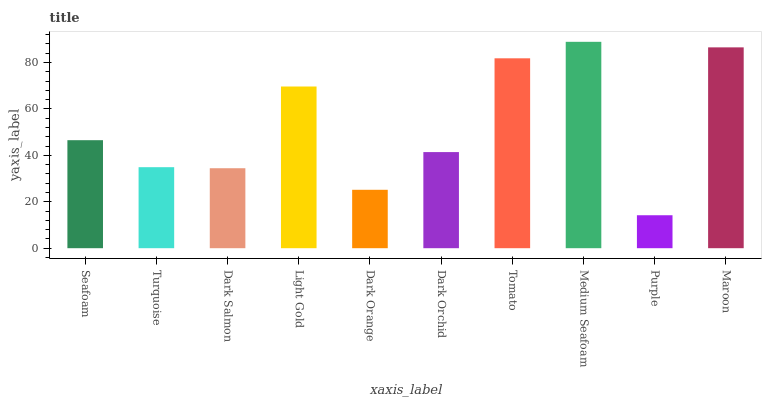Is Purple the minimum?
Answer yes or no. Yes. Is Medium Seafoam the maximum?
Answer yes or no. Yes. Is Turquoise the minimum?
Answer yes or no. No. Is Turquoise the maximum?
Answer yes or no. No. Is Seafoam greater than Turquoise?
Answer yes or no. Yes. Is Turquoise less than Seafoam?
Answer yes or no. Yes. Is Turquoise greater than Seafoam?
Answer yes or no. No. Is Seafoam less than Turquoise?
Answer yes or no. No. Is Seafoam the high median?
Answer yes or no. Yes. Is Dark Orchid the low median?
Answer yes or no. Yes. Is Light Gold the high median?
Answer yes or no. No. Is Dark Salmon the low median?
Answer yes or no. No. 